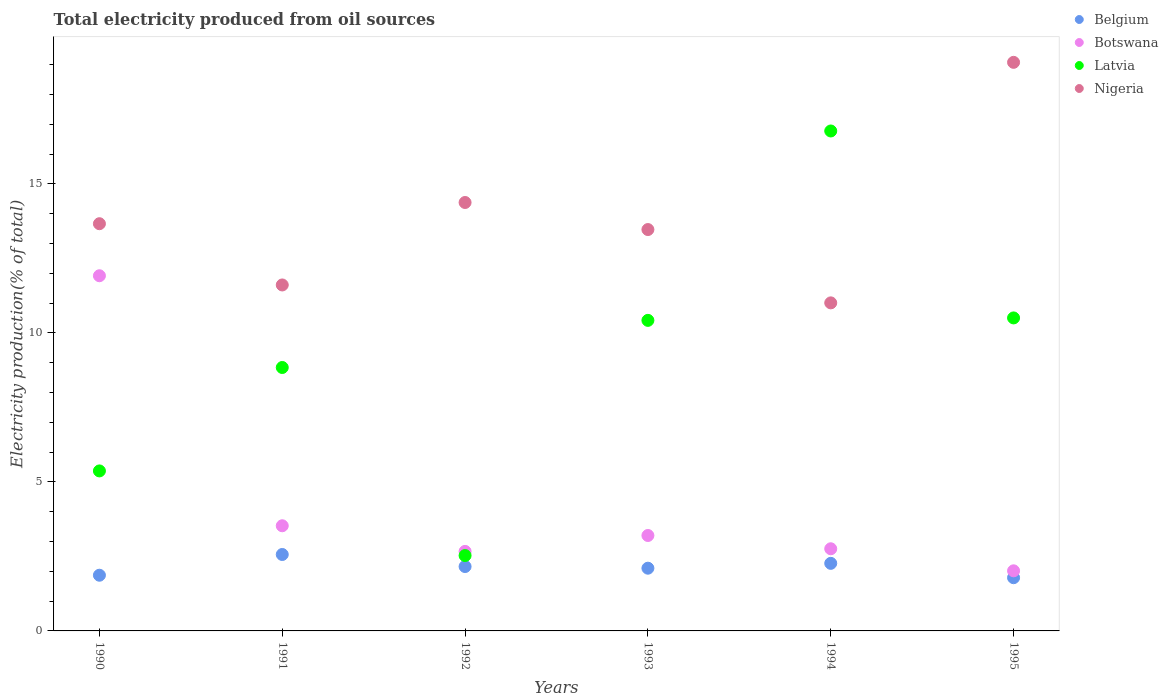What is the total electricity produced in Latvia in 1994?
Provide a succinct answer. 16.78. Across all years, what is the maximum total electricity produced in Nigeria?
Ensure brevity in your answer.  19.08. Across all years, what is the minimum total electricity produced in Latvia?
Your answer should be compact. 2.53. What is the total total electricity produced in Botswana in the graph?
Ensure brevity in your answer.  26.1. What is the difference between the total electricity produced in Latvia in 1994 and that in 1995?
Make the answer very short. 6.27. What is the difference between the total electricity produced in Botswana in 1992 and the total electricity produced in Latvia in 1990?
Make the answer very short. -2.7. What is the average total electricity produced in Nigeria per year?
Offer a terse response. 13.87. In the year 1995, what is the difference between the total electricity produced in Belgium and total electricity produced in Nigeria?
Offer a very short reply. -17.3. In how many years, is the total electricity produced in Belgium greater than 12 %?
Make the answer very short. 0. What is the ratio of the total electricity produced in Belgium in 1990 to that in 1995?
Offer a terse response. 1.05. Is the difference between the total electricity produced in Belgium in 1992 and 1994 greater than the difference between the total electricity produced in Nigeria in 1992 and 1994?
Your answer should be compact. No. What is the difference between the highest and the second highest total electricity produced in Latvia?
Keep it short and to the point. 6.27. What is the difference between the highest and the lowest total electricity produced in Nigeria?
Keep it short and to the point. 8.07. In how many years, is the total electricity produced in Belgium greater than the average total electricity produced in Belgium taken over all years?
Keep it short and to the point. 3. Is the sum of the total electricity produced in Botswana in 1993 and 1995 greater than the maximum total electricity produced in Nigeria across all years?
Your answer should be very brief. No. Is it the case that in every year, the sum of the total electricity produced in Botswana and total electricity produced in Belgium  is greater than the sum of total electricity produced in Nigeria and total electricity produced in Latvia?
Offer a very short reply. No. Is the total electricity produced in Latvia strictly less than the total electricity produced in Nigeria over the years?
Offer a very short reply. No. How many dotlines are there?
Keep it short and to the point. 4. How many years are there in the graph?
Keep it short and to the point. 6. What is the difference between two consecutive major ticks on the Y-axis?
Make the answer very short. 5. Are the values on the major ticks of Y-axis written in scientific E-notation?
Ensure brevity in your answer.  No. Does the graph contain grids?
Provide a succinct answer. No. Where does the legend appear in the graph?
Offer a very short reply. Top right. What is the title of the graph?
Your response must be concise. Total electricity produced from oil sources. What is the label or title of the X-axis?
Give a very brief answer. Years. What is the Electricity production(% of total) in Belgium in 1990?
Offer a very short reply. 1.87. What is the Electricity production(% of total) in Botswana in 1990?
Offer a very short reply. 11.92. What is the Electricity production(% of total) in Latvia in 1990?
Keep it short and to the point. 5.37. What is the Electricity production(% of total) of Nigeria in 1990?
Your response must be concise. 13.67. What is the Electricity production(% of total) in Belgium in 1991?
Your answer should be very brief. 2.57. What is the Electricity production(% of total) of Botswana in 1991?
Your answer should be compact. 3.53. What is the Electricity production(% of total) of Latvia in 1991?
Your response must be concise. 8.84. What is the Electricity production(% of total) in Nigeria in 1991?
Ensure brevity in your answer.  11.61. What is the Electricity production(% of total) of Belgium in 1992?
Ensure brevity in your answer.  2.16. What is the Electricity production(% of total) in Botswana in 1992?
Provide a succinct answer. 2.67. What is the Electricity production(% of total) of Latvia in 1992?
Your answer should be compact. 2.53. What is the Electricity production(% of total) in Nigeria in 1992?
Your response must be concise. 14.38. What is the Electricity production(% of total) of Belgium in 1993?
Your answer should be very brief. 2.11. What is the Electricity production(% of total) of Botswana in 1993?
Ensure brevity in your answer.  3.2. What is the Electricity production(% of total) of Latvia in 1993?
Provide a short and direct response. 10.42. What is the Electricity production(% of total) of Nigeria in 1993?
Your response must be concise. 13.47. What is the Electricity production(% of total) of Belgium in 1994?
Ensure brevity in your answer.  2.27. What is the Electricity production(% of total) of Botswana in 1994?
Give a very brief answer. 2.76. What is the Electricity production(% of total) of Latvia in 1994?
Your answer should be very brief. 16.78. What is the Electricity production(% of total) of Nigeria in 1994?
Offer a terse response. 11.01. What is the Electricity production(% of total) in Belgium in 1995?
Ensure brevity in your answer.  1.79. What is the Electricity production(% of total) in Botswana in 1995?
Provide a succinct answer. 2.02. What is the Electricity production(% of total) in Latvia in 1995?
Make the answer very short. 10.51. What is the Electricity production(% of total) of Nigeria in 1995?
Provide a succinct answer. 19.08. Across all years, what is the maximum Electricity production(% of total) of Belgium?
Your response must be concise. 2.57. Across all years, what is the maximum Electricity production(% of total) in Botswana?
Provide a short and direct response. 11.92. Across all years, what is the maximum Electricity production(% of total) of Latvia?
Ensure brevity in your answer.  16.78. Across all years, what is the maximum Electricity production(% of total) in Nigeria?
Keep it short and to the point. 19.08. Across all years, what is the minimum Electricity production(% of total) of Belgium?
Offer a very short reply. 1.79. Across all years, what is the minimum Electricity production(% of total) of Botswana?
Your answer should be compact. 2.02. Across all years, what is the minimum Electricity production(% of total) of Latvia?
Your answer should be very brief. 2.53. Across all years, what is the minimum Electricity production(% of total) of Nigeria?
Make the answer very short. 11.01. What is the total Electricity production(% of total) of Belgium in the graph?
Offer a terse response. 12.75. What is the total Electricity production(% of total) of Botswana in the graph?
Make the answer very short. 26.1. What is the total Electricity production(% of total) of Latvia in the graph?
Offer a very short reply. 54.45. What is the total Electricity production(% of total) in Nigeria in the graph?
Your answer should be compact. 83.22. What is the difference between the Electricity production(% of total) of Belgium in 1990 and that in 1991?
Your answer should be compact. -0.7. What is the difference between the Electricity production(% of total) of Botswana in 1990 and that in 1991?
Give a very brief answer. 8.39. What is the difference between the Electricity production(% of total) in Latvia in 1990 and that in 1991?
Ensure brevity in your answer.  -3.47. What is the difference between the Electricity production(% of total) in Nigeria in 1990 and that in 1991?
Offer a terse response. 2.06. What is the difference between the Electricity production(% of total) of Belgium in 1990 and that in 1992?
Give a very brief answer. -0.29. What is the difference between the Electricity production(% of total) in Botswana in 1990 and that in 1992?
Give a very brief answer. 9.25. What is the difference between the Electricity production(% of total) in Latvia in 1990 and that in 1992?
Give a very brief answer. 2.84. What is the difference between the Electricity production(% of total) of Nigeria in 1990 and that in 1992?
Your response must be concise. -0.71. What is the difference between the Electricity production(% of total) in Belgium in 1990 and that in 1993?
Give a very brief answer. -0.24. What is the difference between the Electricity production(% of total) of Botswana in 1990 and that in 1993?
Your answer should be very brief. 8.72. What is the difference between the Electricity production(% of total) in Latvia in 1990 and that in 1993?
Your answer should be compact. -5.05. What is the difference between the Electricity production(% of total) in Nigeria in 1990 and that in 1993?
Your answer should be compact. 0.2. What is the difference between the Electricity production(% of total) in Belgium in 1990 and that in 1994?
Provide a short and direct response. -0.4. What is the difference between the Electricity production(% of total) of Botswana in 1990 and that in 1994?
Provide a short and direct response. 9.16. What is the difference between the Electricity production(% of total) in Latvia in 1990 and that in 1994?
Your answer should be compact. -11.41. What is the difference between the Electricity production(% of total) in Nigeria in 1990 and that in 1994?
Keep it short and to the point. 2.66. What is the difference between the Electricity production(% of total) of Belgium in 1990 and that in 1995?
Keep it short and to the point. 0.08. What is the difference between the Electricity production(% of total) of Botswana in 1990 and that in 1995?
Keep it short and to the point. 9.9. What is the difference between the Electricity production(% of total) in Latvia in 1990 and that in 1995?
Offer a very short reply. -5.14. What is the difference between the Electricity production(% of total) in Nigeria in 1990 and that in 1995?
Make the answer very short. -5.42. What is the difference between the Electricity production(% of total) in Belgium in 1991 and that in 1992?
Offer a terse response. 0.4. What is the difference between the Electricity production(% of total) in Botswana in 1991 and that in 1992?
Your answer should be very brief. 0.86. What is the difference between the Electricity production(% of total) in Latvia in 1991 and that in 1992?
Keep it short and to the point. 6.31. What is the difference between the Electricity production(% of total) in Nigeria in 1991 and that in 1992?
Your answer should be compact. -2.77. What is the difference between the Electricity production(% of total) of Belgium in 1991 and that in 1993?
Offer a terse response. 0.46. What is the difference between the Electricity production(% of total) in Botswana in 1991 and that in 1993?
Offer a very short reply. 0.33. What is the difference between the Electricity production(% of total) in Latvia in 1991 and that in 1993?
Give a very brief answer. -1.58. What is the difference between the Electricity production(% of total) of Nigeria in 1991 and that in 1993?
Keep it short and to the point. -1.86. What is the difference between the Electricity production(% of total) in Belgium in 1991 and that in 1994?
Give a very brief answer. 0.3. What is the difference between the Electricity production(% of total) in Botswana in 1991 and that in 1994?
Ensure brevity in your answer.  0.77. What is the difference between the Electricity production(% of total) in Latvia in 1991 and that in 1994?
Your answer should be very brief. -7.94. What is the difference between the Electricity production(% of total) in Nigeria in 1991 and that in 1994?
Your response must be concise. 0.6. What is the difference between the Electricity production(% of total) of Belgium in 1991 and that in 1995?
Keep it short and to the point. 0.78. What is the difference between the Electricity production(% of total) in Botswana in 1991 and that in 1995?
Provide a short and direct response. 1.51. What is the difference between the Electricity production(% of total) of Latvia in 1991 and that in 1995?
Make the answer very short. -1.66. What is the difference between the Electricity production(% of total) in Nigeria in 1991 and that in 1995?
Keep it short and to the point. -7.47. What is the difference between the Electricity production(% of total) of Belgium in 1992 and that in 1993?
Your response must be concise. 0.06. What is the difference between the Electricity production(% of total) in Botswana in 1992 and that in 1993?
Your answer should be very brief. -0.53. What is the difference between the Electricity production(% of total) in Latvia in 1992 and that in 1993?
Ensure brevity in your answer.  -7.89. What is the difference between the Electricity production(% of total) of Nigeria in 1992 and that in 1993?
Keep it short and to the point. 0.91. What is the difference between the Electricity production(% of total) in Belgium in 1992 and that in 1994?
Provide a succinct answer. -0.11. What is the difference between the Electricity production(% of total) in Botswana in 1992 and that in 1994?
Give a very brief answer. -0.09. What is the difference between the Electricity production(% of total) in Latvia in 1992 and that in 1994?
Your answer should be very brief. -14.25. What is the difference between the Electricity production(% of total) in Nigeria in 1992 and that in 1994?
Offer a terse response. 3.37. What is the difference between the Electricity production(% of total) of Belgium in 1992 and that in 1995?
Ensure brevity in your answer.  0.37. What is the difference between the Electricity production(% of total) of Botswana in 1992 and that in 1995?
Provide a succinct answer. 0.65. What is the difference between the Electricity production(% of total) in Latvia in 1992 and that in 1995?
Your answer should be very brief. -7.98. What is the difference between the Electricity production(% of total) of Nigeria in 1992 and that in 1995?
Give a very brief answer. -4.7. What is the difference between the Electricity production(% of total) of Belgium in 1993 and that in 1994?
Your answer should be very brief. -0.16. What is the difference between the Electricity production(% of total) in Botswana in 1993 and that in 1994?
Ensure brevity in your answer.  0.45. What is the difference between the Electricity production(% of total) in Latvia in 1993 and that in 1994?
Your answer should be very brief. -6.36. What is the difference between the Electricity production(% of total) in Nigeria in 1993 and that in 1994?
Your answer should be very brief. 2.46. What is the difference between the Electricity production(% of total) of Belgium in 1993 and that in 1995?
Provide a succinct answer. 0.32. What is the difference between the Electricity production(% of total) of Botswana in 1993 and that in 1995?
Offer a very short reply. 1.19. What is the difference between the Electricity production(% of total) of Latvia in 1993 and that in 1995?
Make the answer very short. -0.08. What is the difference between the Electricity production(% of total) of Nigeria in 1993 and that in 1995?
Your answer should be compact. -5.61. What is the difference between the Electricity production(% of total) of Belgium in 1994 and that in 1995?
Offer a terse response. 0.48. What is the difference between the Electricity production(% of total) of Botswana in 1994 and that in 1995?
Your answer should be compact. 0.74. What is the difference between the Electricity production(% of total) in Latvia in 1994 and that in 1995?
Keep it short and to the point. 6.27. What is the difference between the Electricity production(% of total) of Nigeria in 1994 and that in 1995?
Your answer should be compact. -8.07. What is the difference between the Electricity production(% of total) of Belgium in 1990 and the Electricity production(% of total) of Botswana in 1991?
Provide a succinct answer. -1.66. What is the difference between the Electricity production(% of total) in Belgium in 1990 and the Electricity production(% of total) in Latvia in 1991?
Make the answer very short. -6.97. What is the difference between the Electricity production(% of total) in Belgium in 1990 and the Electricity production(% of total) in Nigeria in 1991?
Provide a succinct answer. -9.74. What is the difference between the Electricity production(% of total) of Botswana in 1990 and the Electricity production(% of total) of Latvia in 1991?
Make the answer very short. 3.08. What is the difference between the Electricity production(% of total) of Botswana in 1990 and the Electricity production(% of total) of Nigeria in 1991?
Make the answer very short. 0.31. What is the difference between the Electricity production(% of total) of Latvia in 1990 and the Electricity production(% of total) of Nigeria in 1991?
Your answer should be very brief. -6.24. What is the difference between the Electricity production(% of total) of Belgium in 1990 and the Electricity production(% of total) of Botswana in 1992?
Offer a terse response. -0.8. What is the difference between the Electricity production(% of total) in Belgium in 1990 and the Electricity production(% of total) in Latvia in 1992?
Provide a short and direct response. -0.66. What is the difference between the Electricity production(% of total) of Belgium in 1990 and the Electricity production(% of total) of Nigeria in 1992?
Keep it short and to the point. -12.51. What is the difference between the Electricity production(% of total) in Botswana in 1990 and the Electricity production(% of total) in Latvia in 1992?
Provide a short and direct response. 9.39. What is the difference between the Electricity production(% of total) of Botswana in 1990 and the Electricity production(% of total) of Nigeria in 1992?
Your answer should be compact. -2.46. What is the difference between the Electricity production(% of total) in Latvia in 1990 and the Electricity production(% of total) in Nigeria in 1992?
Your answer should be very brief. -9.01. What is the difference between the Electricity production(% of total) in Belgium in 1990 and the Electricity production(% of total) in Botswana in 1993?
Offer a very short reply. -1.33. What is the difference between the Electricity production(% of total) in Belgium in 1990 and the Electricity production(% of total) in Latvia in 1993?
Keep it short and to the point. -8.55. What is the difference between the Electricity production(% of total) of Belgium in 1990 and the Electricity production(% of total) of Nigeria in 1993?
Your response must be concise. -11.6. What is the difference between the Electricity production(% of total) in Botswana in 1990 and the Electricity production(% of total) in Latvia in 1993?
Provide a succinct answer. 1.5. What is the difference between the Electricity production(% of total) in Botswana in 1990 and the Electricity production(% of total) in Nigeria in 1993?
Keep it short and to the point. -1.55. What is the difference between the Electricity production(% of total) of Latvia in 1990 and the Electricity production(% of total) of Nigeria in 1993?
Keep it short and to the point. -8.1. What is the difference between the Electricity production(% of total) in Belgium in 1990 and the Electricity production(% of total) in Botswana in 1994?
Ensure brevity in your answer.  -0.89. What is the difference between the Electricity production(% of total) of Belgium in 1990 and the Electricity production(% of total) of Latvia in 1994?
Provide a short and direct response. -14.91. What is the difference between the Electricity production(% of total) of Belgium in 1990 and the Electricity production(% of total) of Nigeria in 1994?
Provide a succinct answer. -9.14. What is the difference between the Electricity production(% of total) in Botswana in 1990 and the Electricity production(% of total) in Latvia in 1994?
Provide a short and direct response. -4.86. What is the difference between the Electricity production(% of total) in Botswana in 1990 and the Electricity production(% of total) in Nigeria in 1994?
Ensure brevity in your answer.  0.91. What is the difference between the Electricity production(% of total) of Latvia in 1990 and the Electricity production(% of total) of Nigeria in 1994?
Make the answer very short. -5.64. What is the difference between the Electricity production(% of total) in Belgium in 1990 and the Electricity production(% of total) in Botswana in 1995?
Provide a short and direct response. -0.15. What is the difference between the Electricity production(% of total) of Belgium in 1990 and the Electricity production(% of total) of Latvia in 1995?
Provide a short and direct response. -8.64. What is the difference between the Electricity production(% of total) of Belgium in 1990 and the Electricity production(% of total) of Nigeria in 1995?
Ensure brevity in your answer.  -17.21. What is the difference between the Electricity production(% of total) of Botswana in 1990 and the Electricity production(% of total) of Latvia in 1995?
Ensure brevity in your answer.  1.42. What is the difference between the Electricity production(% of total) in Botswana in 1990 and the Electricity production(% of total) in Nigeria in 1995?
Provide a succinct answer. -7.16. What is the difference between the Electricity production(% of total) of Latvia in 1990 and the Electricity production(% of total) of Nigeria in 1995?
Give a very brief answer. -13.71. What is the difference between the Electricity production(% of total) of Belgium in 1991 and the Electricity production(% of total) of Botswana in 1992?
Keep it short and to the point. -0.1. What is the difference between the Electricity production(% of total) of Belgium in 1991 and the Electricity production(% of total) of Latvia in 1992?
Your response must be concise. 0.04. What is the difference between the Electricity production(% of total) in Belgium in 1991 and the Electricity production(% of total) in Nigeria in 1992?
Offer a terse response. -11.81. What is the difference between the Electricity production(% of total) in Botswana in 1991 and the Electricity production(% of total) in Nigeria in 1992?
Make the answer very short. -10.85. What is the difference between the Electricity production(% of total) in Latvia in 1991 and the Electricity production(% of total) in Nigeria in 1992?
Provide a short and direct response. -5.54. What is the difference between the Electricity production(% of total) of Belgium in 1991 and the Electricity production(% of total) of Botswana in 1993?
Provide a short and direct response. -0.64. What is the difference between the Electricity production(% of total) of Belgium in 1991 and the Electricity production(% of total) of Latvia in 1993?
Provide a succinct answer. -7.86. What is the difference between the Electricity production(% of total) in Belgium in 1991 and the Electricity production(% of total) in Nigeria in 1993?
Give a very brief answer. -10.91. What is the difference between the Electricity production(% of total) in Botswana in 1991 and the Electricity production(% of total) in Latvia in 1993?
Offer a very short reply. -6.89. What is the difference between the Electricity production(% of total) of Botswana in 1991 and the Electricity production(% of total) of Nigeria in 1993?
Your answer should be compact. -9.94. What is the difference between the Electricity production(% of total) in Latvia in 1991 and the Electricity production(% of total) in Nigeria in 1993?
Give a very brief answer. -4.63. What is the difference between the Electricity production(% of total) of Belgium in 1991 and the Electricity production(% of total) of Botswana in 1994?
Keep it short and to the point. -0.19. What is the difference between the Electricity production(% of total) in Belgium in 1991 and the Electricity production(% of total) in Latvia in 1994?
Provide a short and direct response. -14.21. What is the difference between the Electricity production(% of total) of Belgium in 1991 and the Electricity production(% of total) of Nigeria in 1994?
Your answer should be compact. -8.45. What is the difference between the Electricity production(% of total) in Botswana in 1991 and the Electricity production(% of total) in Latvia in 1994?
Give a very brief answer. -13.25. What is the difference between the Electricity production(% of total) in Botswana in 1991 and the Electricity production(% of total) in Nigeria in 1994?
Your answer should be compact. -7.48. What is the difference between the Electricity production(% of total) of Latvia in 1991 and the Electricity production(% of total) of Nigeria in 1994?
Keep it short and to the point. -2.17. What is the difference between the Electricity production(% of total) in Belgium in 1991 and the Electricity production(% of total) in Botswana in 1995?
Provide a short and direct response. 0.55. What is the difference between the Electricity production(% of total) of Belgium in 1991 and the Electricity production(% of total) of Latvia in 1995?
Your answer should be compact. -7.94. What is the difference between the Electricity production(% of total) of Belgium in 1991 and the Electricity production(% of total) of Nigeria in 1995?
Provide a short and direct response. -16.52. What is the difference between the Electricity production(% of total) of Botswana in 1991 and the Electricity production(% of total) of Latvia in 1995?
Your response must be concise. -6.98. What is the difference between the Electricity production(% of total) in Botswana in 1991 and the Electricity production(% of total) in Nigeria in 1995?
Offer a terse response. -15.55. What is the difference between the Electricity production(% of total) of Latvia in 1991 and the Electricity production(% of total) of Nigeria in 1995?
Make the answer very short. -10.24. What is the difference between the Electricity production(% of total) of Belgium in 1992 and the Electricity production(% of total) of Botswana in 1993?
Keep it short and to the point. -1.04. What is the difference between the Electricity production(% of total) in Belgium in 1992 and the Electricity production(% of total) in Latvia in 1993?
Offer a terse response. -8.26. What is the difference between the Electricity production(% of total) in Belgium in 1992 and the Electricity production(% of total) in Nigeria in 1993?
Offer a very short reply. -11.31. What is the difference between the Electricity production(% of total) in Botswana in 1992 and the Electricity production(% of total) in Latvia in 1993?
Keep it short and to the point. -7.75. What is the difference between the Electricity production(% of total) in Botswana in 1992 and the Electricity production(% of total) in Nigeria in 1993?
Your response must be concise. -10.8. What is the difference between the Electricity production(% of total) of Latvia in 1992 and the Electricity production(% of total) of Nigeria in 1993?
Offer a terse response. -10.94. What is the difference between the Electricity production(% of total) in Belgium in 1992 and the Electricity production(% of total) in Botswana in 1994?
Offer a very short reply. -0.6. What is the difference between the Electricity production(% of total) of Belgium in 1992 and the Electricity production(% of total) of Latvia in 1994?
Offer a very short reply. -14.62. What is the difference between the Electricity production(% of total) of Belgium in 1992 and the Electricity production(% of total) of Nigeria in 1994?
Provide a short and direct response. -8.85. What is the difference between the Electricity production(% of total) of Botswana in 1992 and the Electricity production(% of total) of Latvia in 1994?
Your response must be concise. -14.11. What is the difference between the Electricity production(% of total) in Botswana in 1992 and the Electricity production(% of total) in Nigeria in 1994?
Keep it short and to the point. -8.34. What is the difference between the Electricity production(% of total) in Latvia in 1992 and the Electricity production(% of total) in Nigeria in 1994?
Make the answer very short. -8.48. What is the difference between the Electricity production(% of total) of Belgium in 1992 and the Electricity production(% of total) of Botswana in 1995?
Ensure brevity in your answer.  0.14. What is the difference between the Electricity production(% of total) in Belgium in 1992 and the Electricity production(% of total) in Latvia in 1995?
Provide a succinct answer. -8.34. What is the difference between the Electricity production(% of total) of Belgium in 1992 and the Electricity production(% of total) of Nigeria in 1995?
Your response must be concise. -16.92. What is the difference between the Electricity production(% of total) of Botswana in 1992 and the Electricity production(% of total) of Latvia in 1995?
Your answer should be compact. -7.84. What is the difference between the Electricity production(% of total) of Botswana in 1992 and the Electricity production(% of total) of Nigeria in 1995?
Provide a short and direct response. -16.41. What is the difference between the Electricity production(% of total) in Latvia in 1992 and the Electricity production(% of total) in Nigeria in 1995?
Your response must be concise. -16.55. What is the difference between the Electricity production(% of total) of Belgium in 1993 and the Electricity production(% of total) of Botswana in 1994?
Your answer should be very brief. -0.65. What is the difference between the Electricity production(% of total) of Belgium in 1993 and the Electricity production(% of total) of Latvia in 1994?
Give a very brief answer. -14.67. What is the difference between the Electricity production(% of total) in Belgium in 1993 and the Electricity production(% of total) in Nigeria in 1994?
Offer a very short reply. -8.91. What is the difference between the Electricity production(% of total) in Botswana in 1993 and the Electricity production(% of total) in Latvia in 1994?
Offer a terse response. -13.58. What is the difference between the Electricity production(% of total) in Botswana in 1993 and the Electricity production(% of total) in Nigeria in 1994?
Keep it short and to the point. -7.81. What is the difference between the Electricity production(% of total) of Latvia in 1993 and the Electricity production(% of total) of Nigeria in 1994?
Provide a short and direct response. -0.59. What is the difference between the Electricity production(% of total) of Belgium in 1993 and the Electricity production(% of total) of Botswana in 1995?
Keep it short and to the point. 0.09. What is the difference between the Electricity production(% of total) of Belgium in 1993 and the Electricity production(% of total) of Latvia in 1995?
Provide a succinct answer. -8.4. What is the difference between the Electricity production(% of total) of Belgium in 1993 and the Electricity production(% of total) of Nigeria in 1995?
Keep it short and to the point. -16.98. What is the difference between the Electricity production(% of total) in Botswana in 1993 and the Electricity production(% of total) in Latvia in 1995?
Offer a terse response. -7.3. What is the difference between the Electricity production(% of total) of Botswana in 1993 and the Electricity production(% of total) of Nigeria in 1995?
Ensure brevity in your answer.  -15.88. What is the difference between the Electricity production(% of total) of Latvia in 1993 and the Electricity production(% of total) of Nigeria in 1995?
Your response must be concise. -8.66. What is the difference between the Electricity production(% of total) in Belgium in 1994 and the Electricity production(% of total) in Botswana in 1995?
Your response must be concise. 0.25. What is the difference between the Electricity production(% of total) of Belgium in 1994 and the Electricity production(% of total) of Latvia in 1995?
Provide a short and direct response. -8.24. What is the difference between the Electricity production(% of total) of Belgium in 1994 and the Electricity production(% of total) of Nigeria in 1995?
Provide a succinct answer. -16.82. What is the difference between the Electricity production(% of total) of Botswana in 1994 and the Electricity production(% of total) of Latvia in 1995?
Offer a very short reply. -7.75. What is the difference between the Electricity production(% of total) of Botswana in 1994 and the Electricity production(% of total) of Nigeria in 1995?
Your response must be concise. -16.33. What is the difference between the Electricity production(% of total) of Latvia in 1994 and the Electricity production(% of total) of Nigeria in 1995?
Offer a terse response. -2.3. What is the average Electricity production(% of total) in Belgium per year?
Offer a terse response. 2.13. What is the average Electricity production(% of total) of Botswana per year?
Keep it short and to the point. 4.35. What is the average Electricity production(% of total) of Latvia per year?
Give a very brief answer. 9.07. What is the average Electricity production(% of total) of Nigeria per year?
Your answer should be very brief. 13.87. In the year 1990, what is the difference between the Electricity production(% of total) in Belgium and Electricity production(% of total) in Botswana?
Offer a terse response. -10.05. In the year 1990, what is the difference between the Electricity production(% of total) of Belgium and Electricity production(% of total) of Latvia?
Provide a succinct answer. -3.5. In the year 1990, what is the difference between the Electricity production(% of total) in Belgium and Electricity production(% of total) in Nigeria?
Keep it short and to the point. -11.8. In the year 1990, what is the difference between the Electricity production(% of total) in Botswana and Electricity production(% of total) in Latvia?
Keep it short and to the point. 6.55. In the year 1990, what is the difference between the Electricity production(% of total) in Botswana and Electricity production(% of total) in Nigeria?
Keep it short and to the point. -1.75. In the year 1990, what is the difference between the Electricity production(% of total) of Latvia and Electricity production(% of total) of Nigeria?
Keep it short and to the point. -8.3. In the year 1991, what is the difference between the Electricity production(% of total) of Belgium and Electricity production(% of total) of Botswana?
Your answer should be very brief. -0.96. In the year 1991, what is the difference between the Electricity production(% of total) of Belgium and Electricity production(% of total) of Latvia?
Keep it short and to the point. -6.28. In the year 1991, what is the difference between the Electricity production(% of total) in Belgium and Electricity production(% of total) in Nigeria?
Provide a short and direct response. -9.05. In the year 1991, what is the difference between the Electricity production(% of total) of Botswana and Electricity production(% of total) of Latvia?
Your answer should be compact. -5.31. In the year 1991, what is the difference between the Electricity production(% of total) of Botswana and Electricity production(% of total) of Nigeria?
Keep it short and to the point. -8.08. In the year 1991, what is the difference between the Electricity production(% of total) of Latvia and Electricity production(% of total) of Nigeria?
Your answer should be very brief. -2.77. In the year 1992, what is the difference between the Electricity production(% of total) in Belgium and Electricity production(% of total) in Botswana?
Keep it short and to the point. -0.51. In the year 1992, what is the difference between the Electricity production(% of total) in Belgium and Electricity production(% of total) in Latvia?
Your answer should be compact. -0.37. In the year 1992, what is the difference between the Electricity production(% of total) of Belgium and Electricity production(% of total) of Nigeria?
Your answer should be very brief. -12.22. In the year 1992, what is the difference between the Electricity production(% of total) in Botswana and Electricity production(% of total) in Latvia?
Provide a succinct answer. 0.14. In the year 1992, what is the difference between the Electricity production(% of total) of Botswana and Electricity production(% of total) of Nigeria?
Make the answer very short. -11.71. In the year 1992, what is the difference between the Electricity production(% of total) of Latvia and Electricity production(% of total) of Nigeria?
Keep it short and to the point. -11.85. In the year 1993, what is the difference between the Electricity production(% of total) in Belgium and Electricity production(% of total) in Botswana?
Offer a terse response. -1.1. In the year 1993, what is the difference between the Electricity production(% of total) of Belgium and Electricity production(% of total) of Latvia?
Ensure brevity in your answer.  -8.32. In the year 1993, what is the difference between the Electricity production(% of total) of Belgium and Electricity production(% of total) of Nigeria?
Give a very brief answer. -11.37. In the year 1993, what is the difference between the Electricity production(% of total) in Botswana and Electricity production(% of total) in Latvia?
Give a very brief answer. -7.22. In the year 1993, what is the difference between the Electricity production(% of total) in Botswana and Electricity production(% of total) in Nigeria?
Provide a short and direct response. -10.27. In the year 1993, what is the difference between the Electricity production(% of total) in Latvia and Electricity production(% of total) in Nigeria?
Offer a terse response. -3.05. In the year 1994, what is the difference between the Electricity production(% of total) of Belgium and Electricity production(% of total) of Botswana?
Ensure brevity in your answer.  -0.49. In the year 1994, what is the difference between the Electricity production(% of total) of Belgium and Electricity production(% of total) of Latvia?
Provide a succinct answer. -14.51. In the year 1994, what is the difference between the Electricity production(% of total) in Belgium and Electricity production(% of total) in Nigeria?
Provide a short and direct response. -8.74. In the year 1994, what is the difference between the Electricity production(% of total) in Botswana and Electricity production(% of total) in Latvia?
Make the answer very short. -14.02. In the year 1994, what is the difference between the Electricity production(% of total) in Botswana and Electricity production(% of total) in Nigeria?
Your answer should be very brief. -8.25. In the year 1994, what is the difference between the Electricity production(% of total) in Latvia and Electricity production(% of total) in Nigeria?
Your answer should be very brief. 5.77. In the year 1995, what is the difference between the Electricity production(% of total) in Belgium and Electricity production(% of total) in Botswana?
Offer a very short reply. -0.23. In the year 1995, what is the difference between the Electricity production(% of total) in Belgium and Electricity production(% of total) in Latvia?
Your response must be concise. -8.72. In the year 1995, what is the difference between the Electricity production(% of total) of Belgium and Electricity production(% of total) of Nigeria?
Your response must be concise. -17.3. In the year 1995, what is the difference between the Electricity production(% of total) in Botswana and Electricity production(% of total) in Latvia?
Your answer should be very brief. -8.49. In the year 1995, what is the difference between the Electricity production(% of total) of Botswana and Electricity production(% of total) of Nigeria?
Keep it short and to the point. -17.07. In the year 1995, what is the difference between the Electricity production(% of total) in Latvia and Electricity production(% of total) in Nigeria?
Your answer should be compact. -8.58. What is the ratio of the Electricity production(% of total) in Belgium in 1990 to that in 1991?
Your response must be concise. 0.73. What is the ratio of the Electricity production(% of total) of Botswana in 1990 to that in 1991?
Ensure brevity in your answer.  3.38. What is the ratio of the Electricity production(% of total) of Latvia in 1990 to that in 1991?
Ensure brevity in your answer.  0.61. What is the ratio of the Electricity production(% of total) of Nigeria in 1990 to that in 1991?
Your answer should be very brief. 1.18. What is the ratio of the Electricity production(% of total) in Belgium in 1990 to that in 1992?
Offer a terse response. 0.87. What is the ratio of the Electricity production(% of total) in Botswana in 1990 to that in 1992?
Provide a short and direct response. 4.47. What is the ratio of the Electricity production(% of total) of Latvia in 1990 to that in 1992?
Offer a terse response. 2.12. What is the ratio of the Electricity production(% of total) of Nigeria in 1990 to that in 1992?
Provide a succinct answer. 0.95. What is the ratio of the Electricity production(% of total) of Belgium in 1990 to that in 1993?
Give a very brief answer. 0.89. What is the ratio of the Electricity production(% of total) of Botswana in 1990 to that in 1993?
Provide a short and direct response. 3.72. What is the ratio of the Electricity production(% of total) in Latvia in 1990 to that in 1993?
Provide a short and direct response. 0.52. What is the ratio of the Electricity production(% of total) of Nigeria in 1990 to that in 1993?
Your answer should be very brief. 1.01. What is the ratio of the Electricity production(% of total) in Belgium in 1990 to that in 1994?
Offer a terse response. 0.82. What is the ratio of the Electricity production(% of total) of Botswana in 1990 to that in 1994?
Offer a very short reply. 4.32. What is the ratio of the Electricity production(% of total) in Latvia in 1990 to that in 1994?
Offer a very short reply. 0.32. What is the ratio of the Electricity production(% of total) of Nigeria in 1990 to that in 1994?
Your response must be concise. 1.24. What is the ratio of the Electricity production(% of total) of Belgium in 1990 to that in 1995?
Provide a short and direct response. 1.05. What is the ratio of the Electricity production(% of total) in Botswana in 1990 to that in 1995?
Provide a short and direct response. 5.91. What is the ratio of the Electricity production(% of total) of Latvia in 1990 to that in 1995?
Your answer should be very brief. 0.51. What is the ratio of the Electricity production(% of total) in Nigeria in 1990 to that in 1995?
Make the answer very short. 0.72. What is the ratio of the Electricity production(% of total) of Belgium in 1991 to that in 1992?
Keep it short and to the point. 1.19. What is the ratio of the Electricity production(% of total) of Botswana in 1991 to that in 1992?
Provide a succinct answer. 1.32. What is the ratio of the Electricity production(% of total) in Latvia in 1991 to that in 1992?
Your response must be concise. 3.49. What is the ratio of the Electricity production(% of total) in Nigeria in 1991 to that in 1992?
Your answer should be compact. 0.81. What is the ratio of the Electricity production(% of total) in Belgium in 1991 to that in 1993?
Make the answer very short. 1.22. What is the ratio of the Electricity production(% of total) of Botswana in 1991 to that in 1993?
Give a very brief answer. 1.1. What is the ratio of the Electricity production(% of total) in Latvia in 1991 to that in 1993?
Offer a very short reply. 0.85. What is the ratio of the Electricity production(% of total) in Nigeria in 1991 to that in 1993?
Your answer should be very brief. 0.86. What is the ratio of the Electricity production(% of total) of Belgium in 1991 to that in 1994?
Give a very brief answer. 1.13. What is the ratio of the Electricity production(% of total) of Botswana in 1991 to that in 1994?
Your answer should be very brief. 1.28. What is the ratio of the Electricity production(% of total) of Latvia in 1991 to that in 1994?
Your response must be concise. 0.53. What is the ratio of the Electricity production(% of total) of Nigeria in 1991 to that in 1994?
Ensure brevity in your answer.  1.05. What is the ratio of the Electricity production(% of total) of Belgium in 1991 to that in 1995?
Ensure brevity in your answer.  1.44. What is the ratio of the Electricity production(% of total) in Botswana in 1991 to that in 1995?
Provide a short and direct response. 1.75. What is the ratio of the Electricity production(% of total) in Latvia in 1991 to that in 1995?
Make the answer very short. 0.84. What is the ratio of the Electricity production(% of total) in Nigeria in 1991 to that in 1995?
Make the answer very short. 0.61. What is the ratio of the Electricity production(% of total) of Belgium in 1992 to that in 1993?
Give a very brief answer. 1.03. What is the ratio of the Electricity production(% of total) in Botswana in 1992 to that in 1993?
Make the answer very short. 0.83. What is the ratio of the Electricity production(% of total) of Latvia in 1992 to that in 1993?
Keep it short and to the point. 0.24. What is the ratio of the Electricity production(% of total) in Nigeria in 1992 to that in 1993?
Ensure brevity in your answer.  1.07. What is the ratio of the Electricity production(% of total) of Belgium in 1992 to that in 1994?
Keep it short and to the point. 0.95. What is the ratio of the Electricity production(% of total) in Botswana in 1992 to that in 1994?
Keep it short and to the point. 0.97. What is the ratio of the Electricity production(% of total) of Latvia in 1992 to that in 1994?
Your response must be concise. 0.15. What is the ratio of the Electricity production(% of total) in Nigeria in 1992 to that in 1994?
Offer a terse response. 1.31. What is the ratio of the Electricity production(% of total) of Belgium in 1992 to that in 1995?
Make the answer very short. 1.21. What is the ratio of the Electricity production(% of total) of Botswana in 1992 to that in 1995?
Offer a very short reply. 1.32. What is the ratio of the Electricity production(% of total) in Latvia in 1992 to that in 1995?
Offer a terse response. 0.24. What is the ratio of the Electricity production(% of total) of Nigeria in 1992 to that in 1995?
Provide a short and direct response. 0.75. What is the ratio of the Electricity production(% of total) of Belgium in 1993 to that in 1994?
Provide a short and direct response. 0.93. What is the ratio of the Electricity production(% of total) in Botswana in 1993 to that in 1994?
Offer a terse response. 1.16. What is the ratio of the Electricity production(% of total) of Latvia in 1993 to that in 1994?
Your response must be concise. 0.62. What is the ratio of the Electricity production(% of total) in Nigeria in 1993 to that in 1994?
Your answer should be compact. 1.22. What is the ratio of the Electricity production(% of total) of Belgium in 1993 to that in 1995?
Offer a terse response. 1.18. What is the ratio of the Electricity production(% of total) in Botswana in 1993 to that in 1995?
Keep it short and to the point. 1.59. What is the ratio of the Electricity production(% of total) of Latvia in 1993 to that in 1995?
Ensure brevity in your answer.  0.99. What is the ratio of the Electricity production(% of total) in Nigeria in 1993 to that in 1995?
Provide a succinct answer. 0.71. What is the ratio of the Electricity production(% of total) of Belgium in 1994 to that in 1995?
Make the answer very short. 1.27. What is the ratio of the Electricity production(% of total) of Botswana in 1994 to that in 1995?
Make the answer very short. 1.37. What is the ratio of the Electricity production(% of total) of Latvia in 1994 to that in 1995?
Offer a terse response. 1.6. What is the ratio of the Electricity production(% of total) in Nigeria in 1994 to that in 1995?
Keep it short and to the point. 0.58. What is the difference between the highest and the second highest Electricity production(% of total) in Belgium?
Your answer should be compact. 0.3. What is the difference between the highest and the second highest Electricity production(% of total) in Botswana?
Give a very brief answer. 8.39. What is the difference between the highest and the second highest Electricity production(% of total) of Latvia?
Ensure brevity in your answer.  6.27. What is the difference between the highest and the second highest Electricity production(% of total) in Nigeria?
Offer a very short reply. 4.7. What is the difference between the highest and the lowest Electricity production(% of total) in Belgium?
Offer a terse response. 0.78. What is the difference between the highest and the lowest Electricity production(% of total) of Botswana?
Provide a short and direct response. 9.9. What is the difference between the highest and the lowest Electricity production(% of total) in Latvia?
Your answer should be compact. 14.25. What is the difference between the highest and the lowest Electricity production(% of total) of Nigeria?
Offer a terse response. 8.07. 